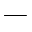Convert formula to latex. <formula><loc_0><loc_0><loc_500><loc_500>-</formula> 